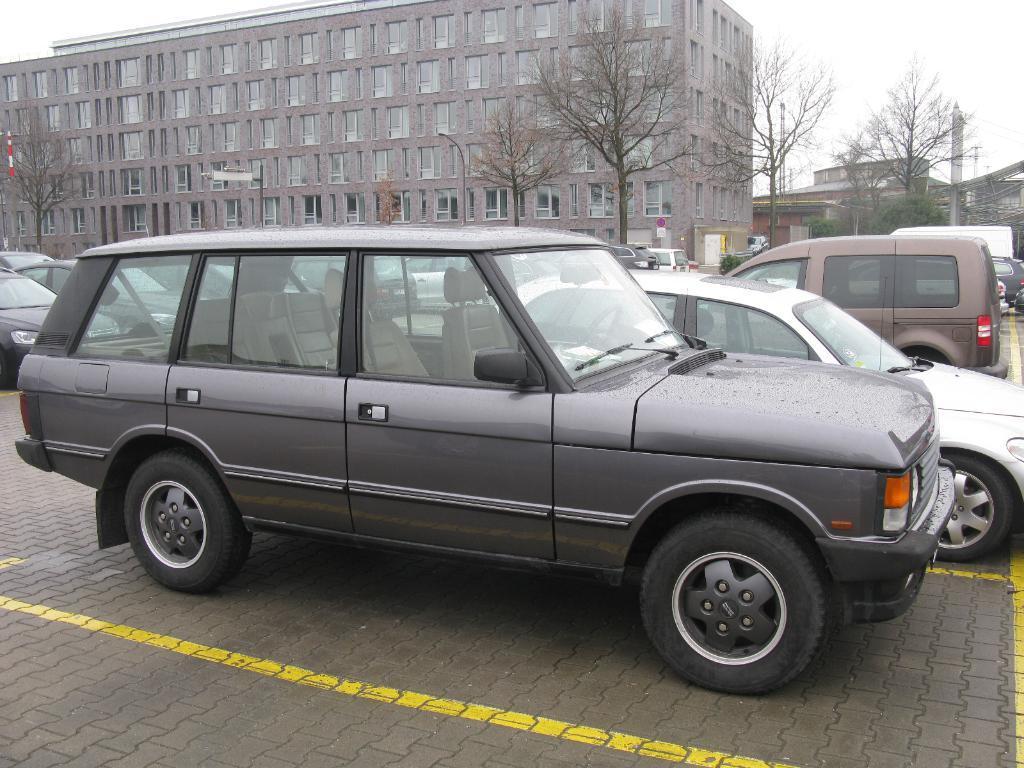Can you describe this image briefly? This is an outside view. Here I can see many cars on the road. In the background there are some buildings and trees. At the top of the image I can see the sky. 